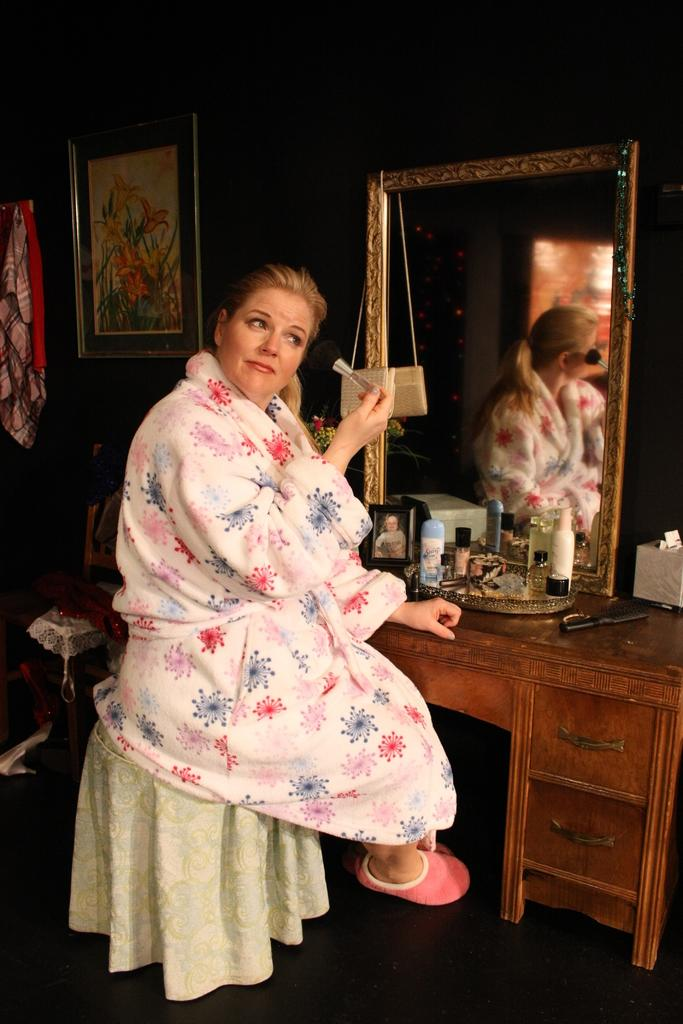Who is the main subject in the image? There is a woman in the image. What is the woman doing in the image? The woman is doing her makeup. What is the woman sitting on in the image? The woman is sitting on a stool. What is the woman wearing on her feet in the image? The woman is wearing pink footwear. What object is in front of the woman in the image? There is a mirror in front of the woman. What can be seen on the wall to the left of the woman in the image? There is a photograph on the wall to the left of the woman. What type of vase is on the table next to the woman in the image? There is no vase present in the image. How does the woman show respect to her makeup tools in the image? The image does not show the woman interacting with her makeup tools in a way that demonstrates respect. 